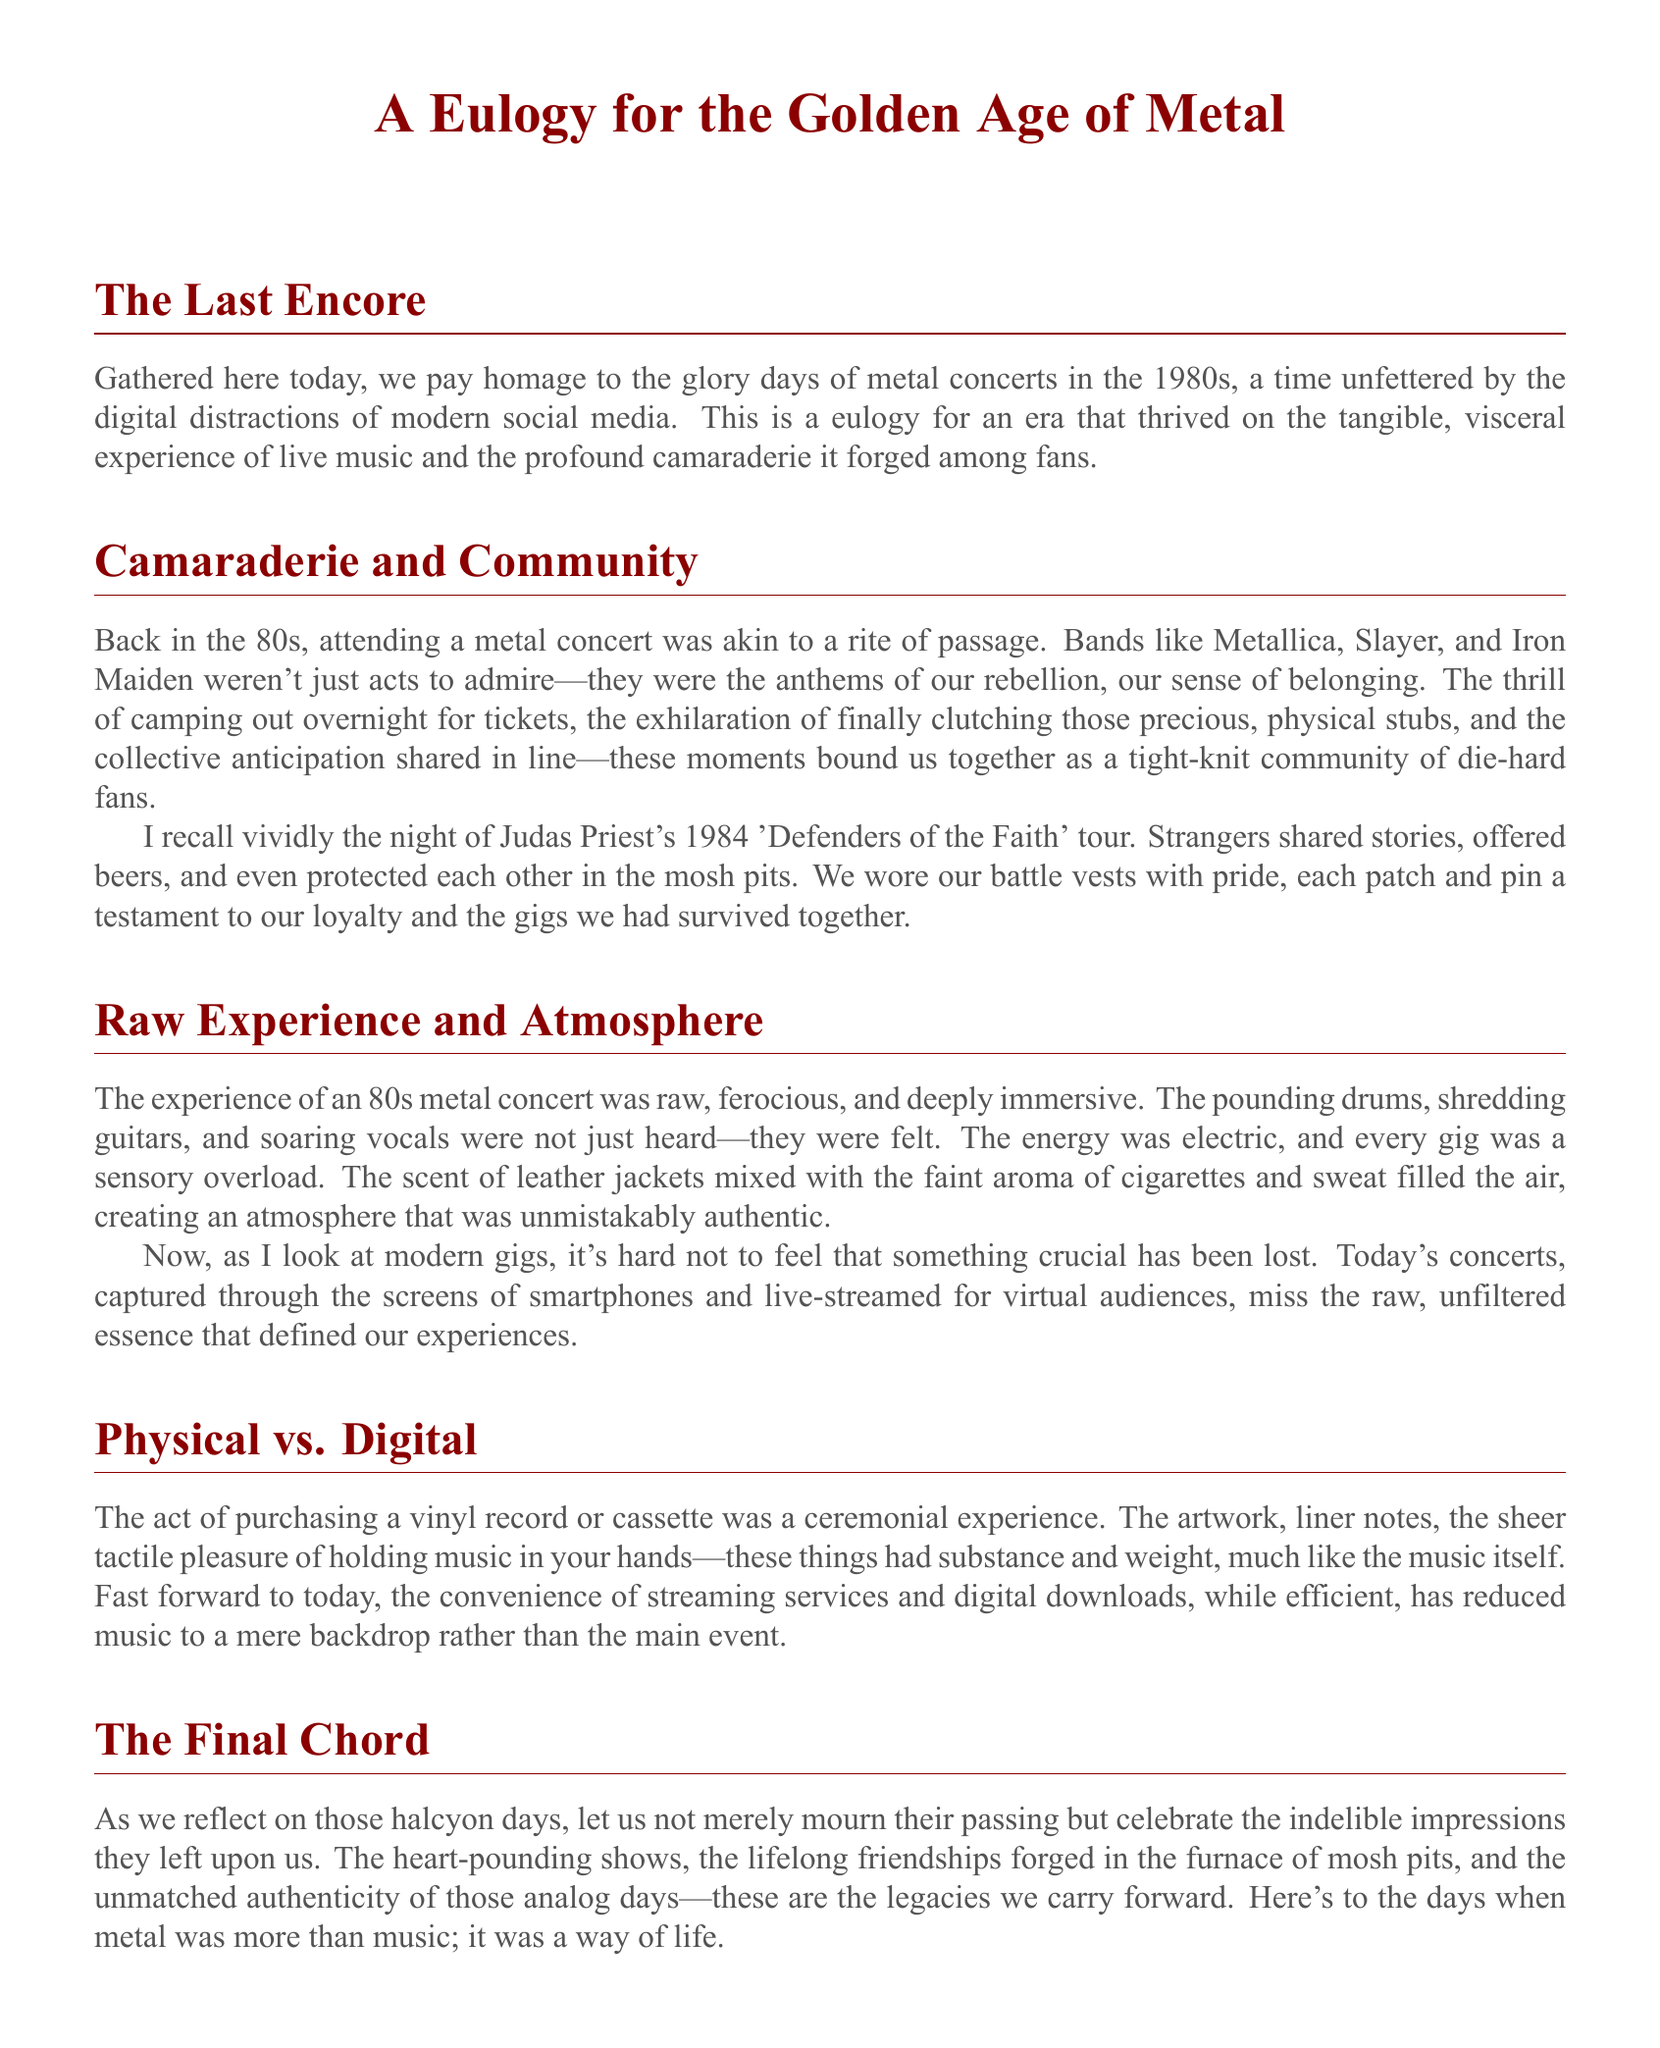What year was Judas Priest's 'Defenders of the Faith' tour? The document mentions the year as 1984 when referring to the Judas Priest concert.
Answer: 1984 Which bands are specifically mentioned in the document? The document lists Metallica, Slayer, and Iron Maiden as the bands that were anthems of rebellion.
Answer: Metallica, Slayer, Iron Maiden What did fans share with each other during concerts? The document states that strangers shared stories, offered beers, and protected each other in the mosh pits, showing the camaraderie present.
Answer: Stories, beers What type of experience does the author associate with 80s metal concerts? The document describes the experience as raw, ferocious, and deeply immersive, highlighting the intensity of these events.
Answer: Raw, ferocious, immersive How did fans obtain concert tickets in the 80s? The document mentions that fans camped out overnight for tickets, emphasizing the dedication and excitement involved.
Answer: Camped out overnight What is the overall theme of the eulogy? The document reflects on the glory days of metal concerts and contrasts it with modern gig culture, focusing on camaraderie and authenticity in live music.
Answer: Glory days of metal concerts What is said about modern concerts compared to 80s concerts? The document argues that modern concerts miss the raw, unfiltered essence that defined the 80s concert experience.
Answer: Miss the raw essence What kind of music purchasing experience is described in the document? The document notes that purchasing a vinyl record or cassette was a ceremonial experience that involved handling physical media.
Answer: Ceremonial experience What is the purpose of the document? The document serves as a eulogy to celebrate the legacy of 80s metal concerts and the community they fostered among fans.
Answer: Celebrate the legacy 